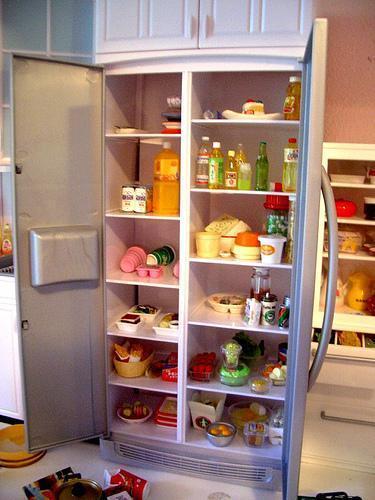How many doors on the refrigerator?
Give a very brief answer. 2. How many refrigerators are in the photo?
Give a very brief answer. 1. 